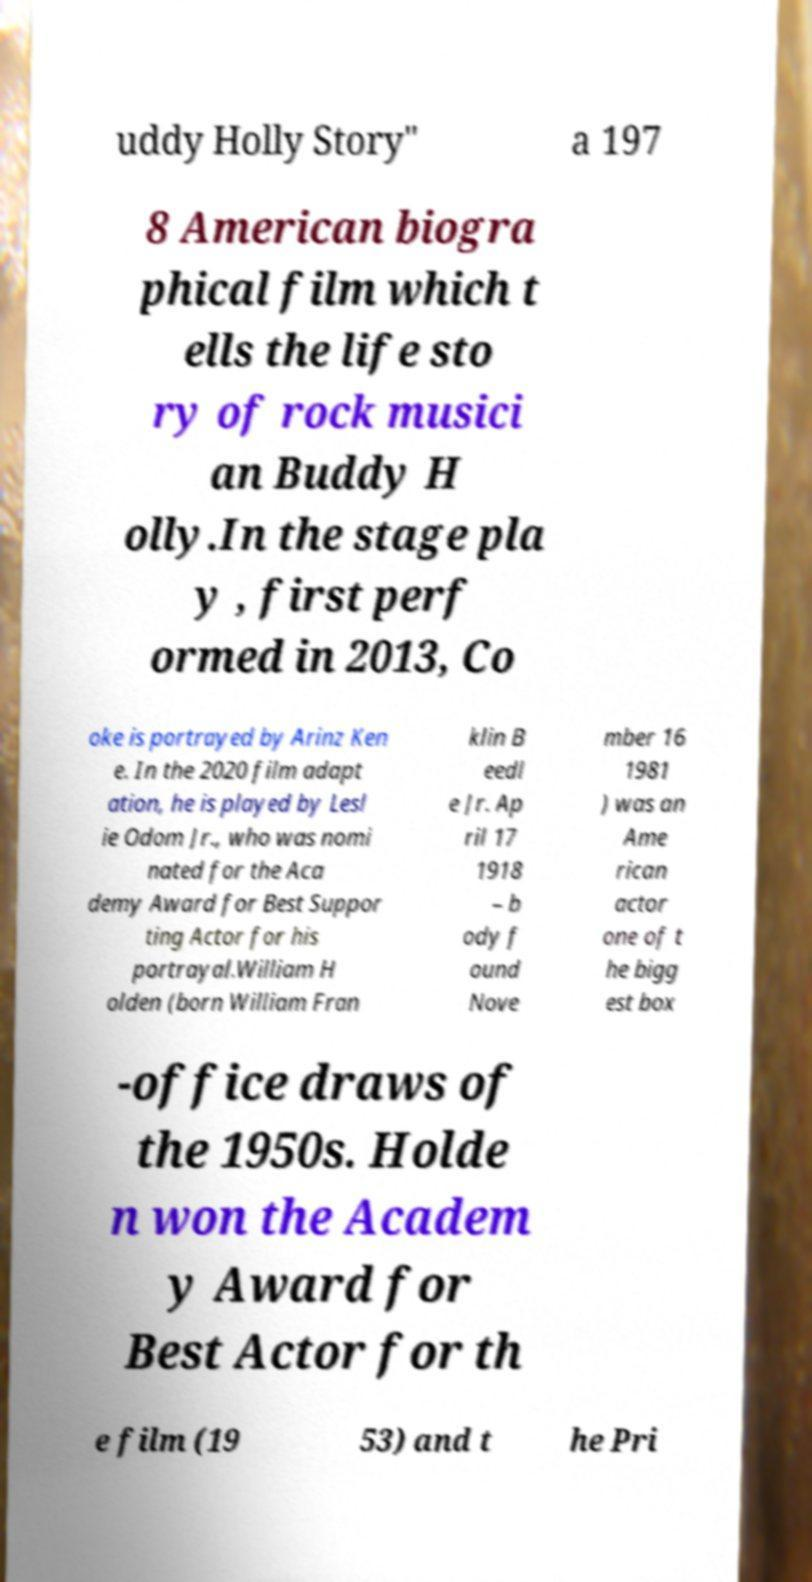Could you extract and type out the text from this image? uddy Holly Story" a 197 8 American biogra phical film which t ells the life sto ry of rock musici an Buddy H olly.In the stage pla y , first perf ormed in 2013, Co oke is portrayed by Arinz Ken e. In the 2020 film adapt ation, he is played by Lesl ie Odom Jr., who was nomi nated for the Aca demy Award for Best Suppor ting Actor for his portrayal.William H olden (born William Fran klin B eedl e Jr. Ap ril 17 1918 – b ody f ound Nove mber 16 1981 ) was an Ame rican actor one of t he bigg est box -office draws of the 1950s. Holde n won the Academ y Award for Best Actor for th e film (19 53) and t he Pri 